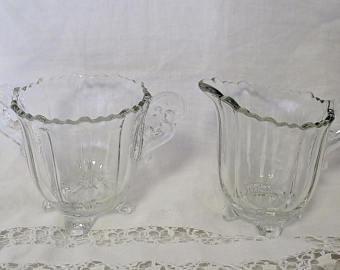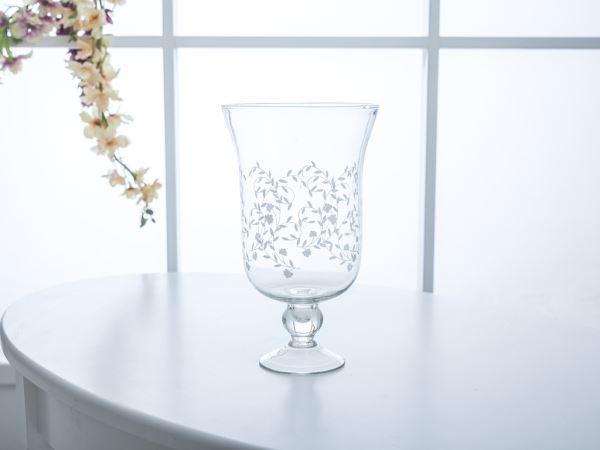The first image is the image on the left, the second image is the image on the right. Given the left and right images, does the statement "There are two clear vases in one of the images." hold true? Answer yes or no. Yes. 